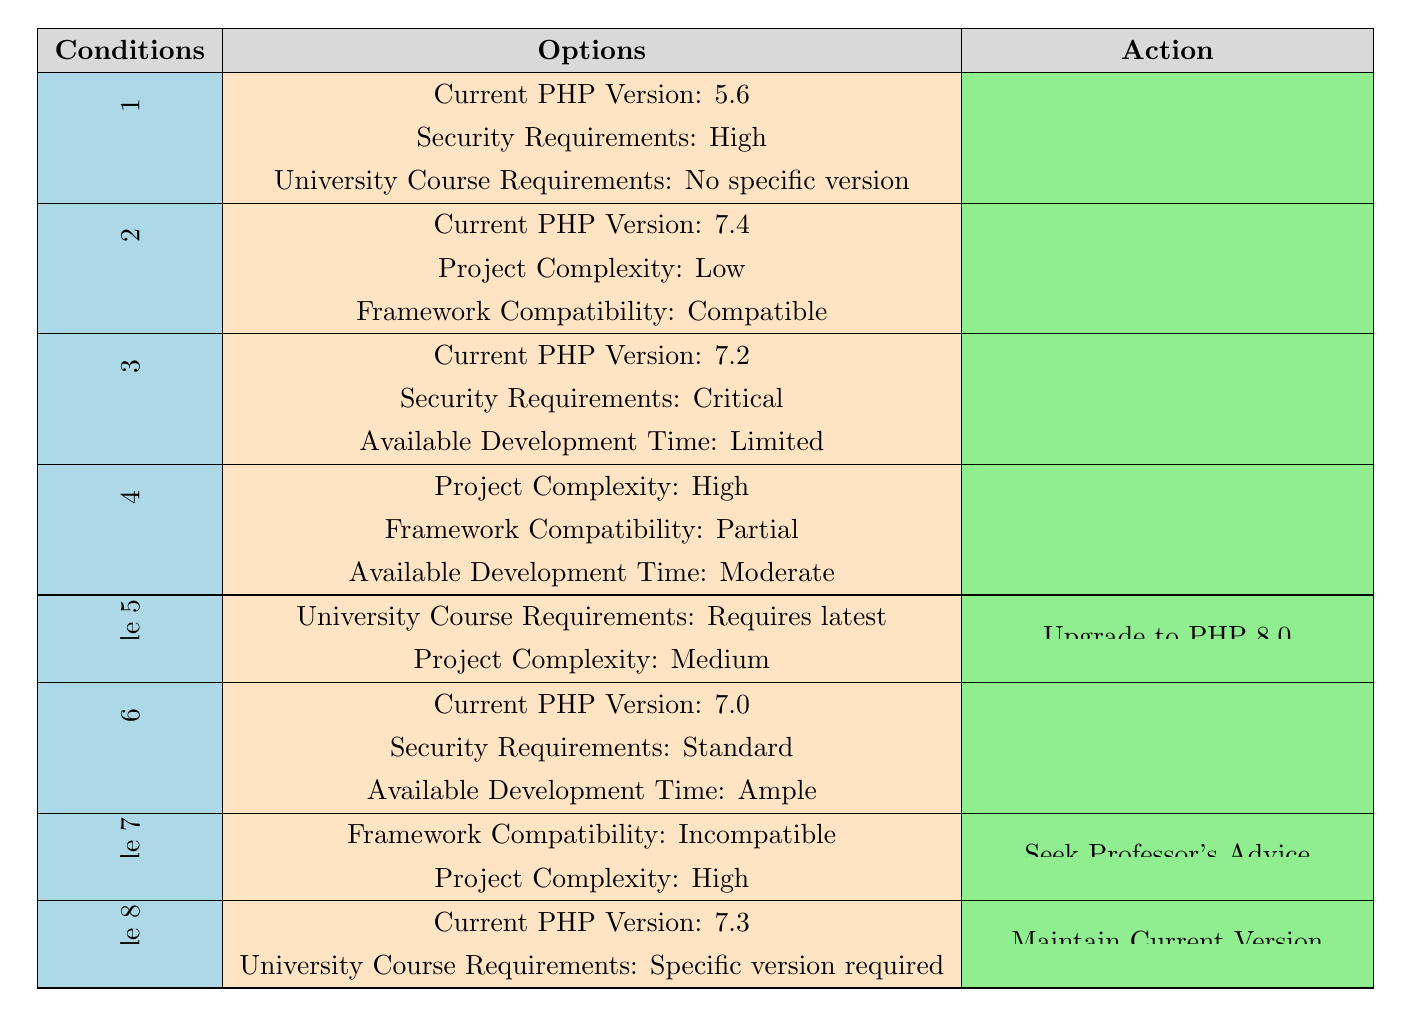What action should be taken if the current PHP version is 5.6 and security requirements are high? According to Rule 1, if the current PHP version is 5.6 and the security requirements are high, the action to take is to upgrade to PHP 7.4.
Answer: Upgrade to PHP 7.4 If a project has medium complexity and course requirements state "requires latest," what action is recommended? Rule 5 specifies that if the university course requirements are "requires latest" and the project complexity is medium, the recommended action is to upgrade to PHP 8.0.
Answer: Upgrade to PHP 8.0 Is it advised to seek a professor's advice if the framework compatibility is incompatible and the project complexity is high? Rule 7 indicates that if framework compatibility is incompatible and project complexity is high, it is advised to seek the professor's advice.
Answer: Yes What action is suggested for a current PHP version of 7.3 with specific version requirements from the university? Rule 8 states that if the current PHP version is 7.3 and there are specific version requirements from the university, the suggested action is to maintain the current version.
Answer: Maintain Current Version In terms of priority, how many actions involve upgrading to PHP 8.0? From the table, the actions that involve upgrading to PHP 8.0 are present in Rule 2 and Rule 5. Thus, there are two actions that involve upgrading to PHP 8.0.
Answer: 2 What is the recommended action if the current PHP version is 7.2, and security requirements are critical with limited development time? According to Rule 3, if the current PHP version is 7.2, security requirements are critical, and available development time is limited, the recommended action is to upgrade to PHP 7.4.
Answer: Upgrade to PHP 7.4 How many total rules in the table recommend conducting compatibility testing? The table shows that Rule 4 recommends conducting compatibility testing due to high project complexity and partial framework compatibility. There is only one rule recommending this action.
Answer: 1 If the available development time is ample and the current PHP version is 7.0 with standard security requirements, what action is recommended? As detailed in Rule 6, if the current PHP version is 7.0, security requirements are standard, and available development time is ample, the recommended action is to upgrade to PHP 7.4.
Answer: Upgrade to PHP 7.4 